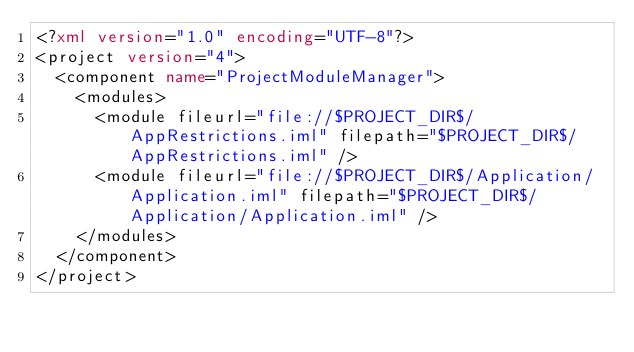<code> <loc_0><loc_0><loc_500><loc_500><_XML_><?xml version="1.0" encoding="UTF-8"?>
<project version="4">
  <component name="ProjectModuleManager">
    <modules>
      <module fileurl="file://$PROJECT_DIR$/AppRestrictions.iml" filepath="$PROJECT_DIR$/AppRestrictions.iml" />
      <module fileurl="file://$PROJECT_DIR$/Application/Application.iml" filepath="$PROJECT_DIR$/Application/Application.iml" />
    </modules>
  </component>
</project>

</code> 